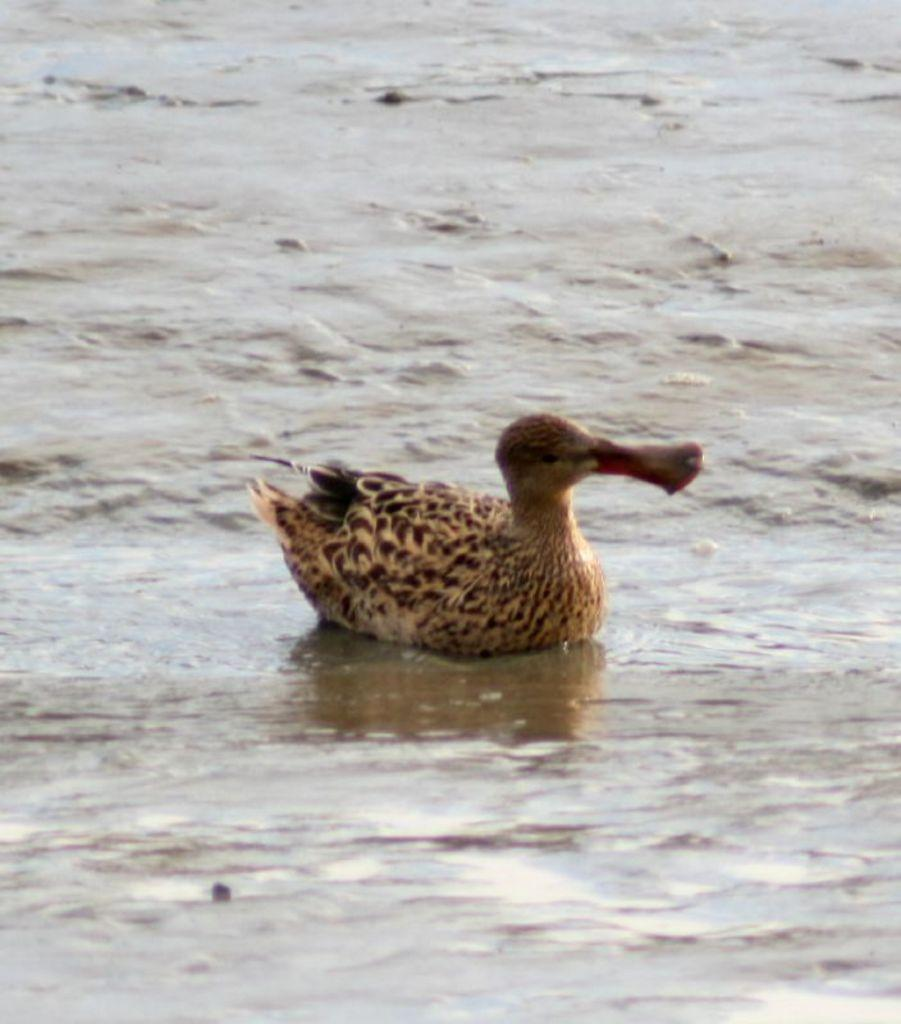What type of animal is present in the image? There is a bird in the image. Where is the bird located? The bird is on the sea shore. What natural elements can be seen in the image? Water and sand are visible in the image. What type of spot does the toad have on its back in the image? There is no toad present in the image, only a bird. What type of voyage is the bird embarking on in the image? The image does not depict the bird embarking on any voyage; it is simply located on the sea shore. 